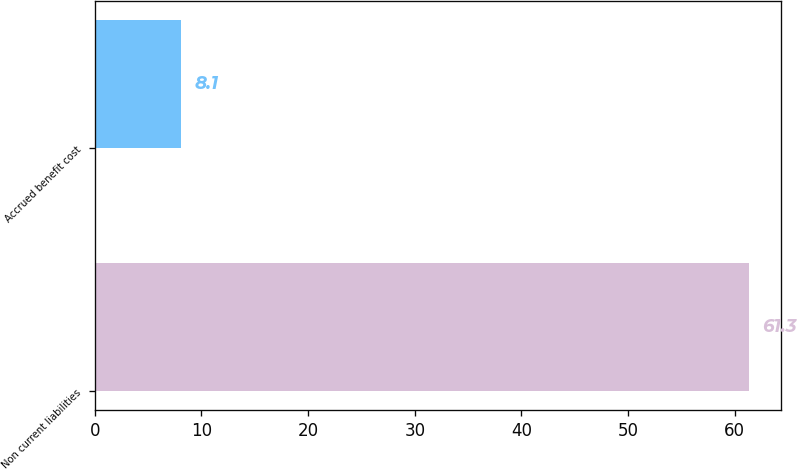Convert chart. <chart><loc_0><loc_0><loc_500><loc_500><bar_chart><fcel>Non current liabilities<fcel>Accrued benefit cost<nl><fcel>61.3<fcel>8.1<nl></chart> 